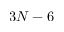<formula> <loc_0><loc_0><loc_500><loc_500>3 N - 6</formula> 